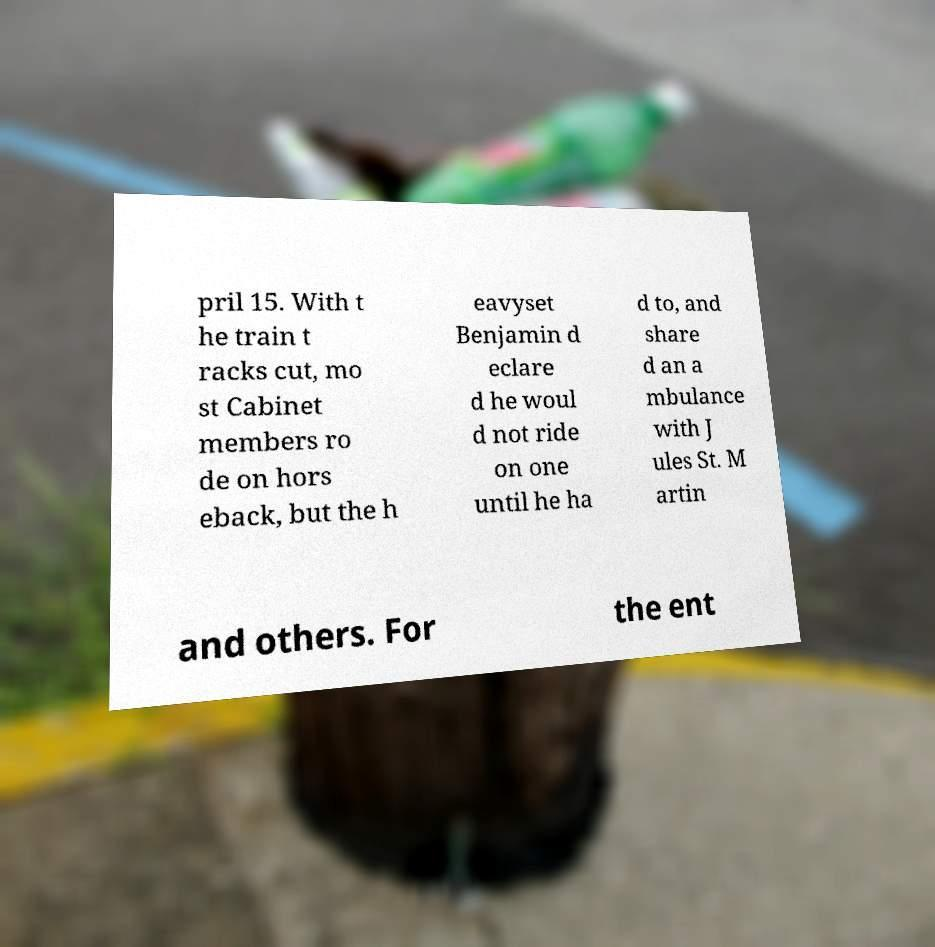Please read and relay the text visible in this image. What does it say? pril 15. With t he train t racks cut, mo st Cabinet members ro de on hors eback, but the h eavyset Benjamin d eclare d he woul d not ride on one until he ha d to, and share d an a mbulance with J ules St. M artin and others. For the ent 